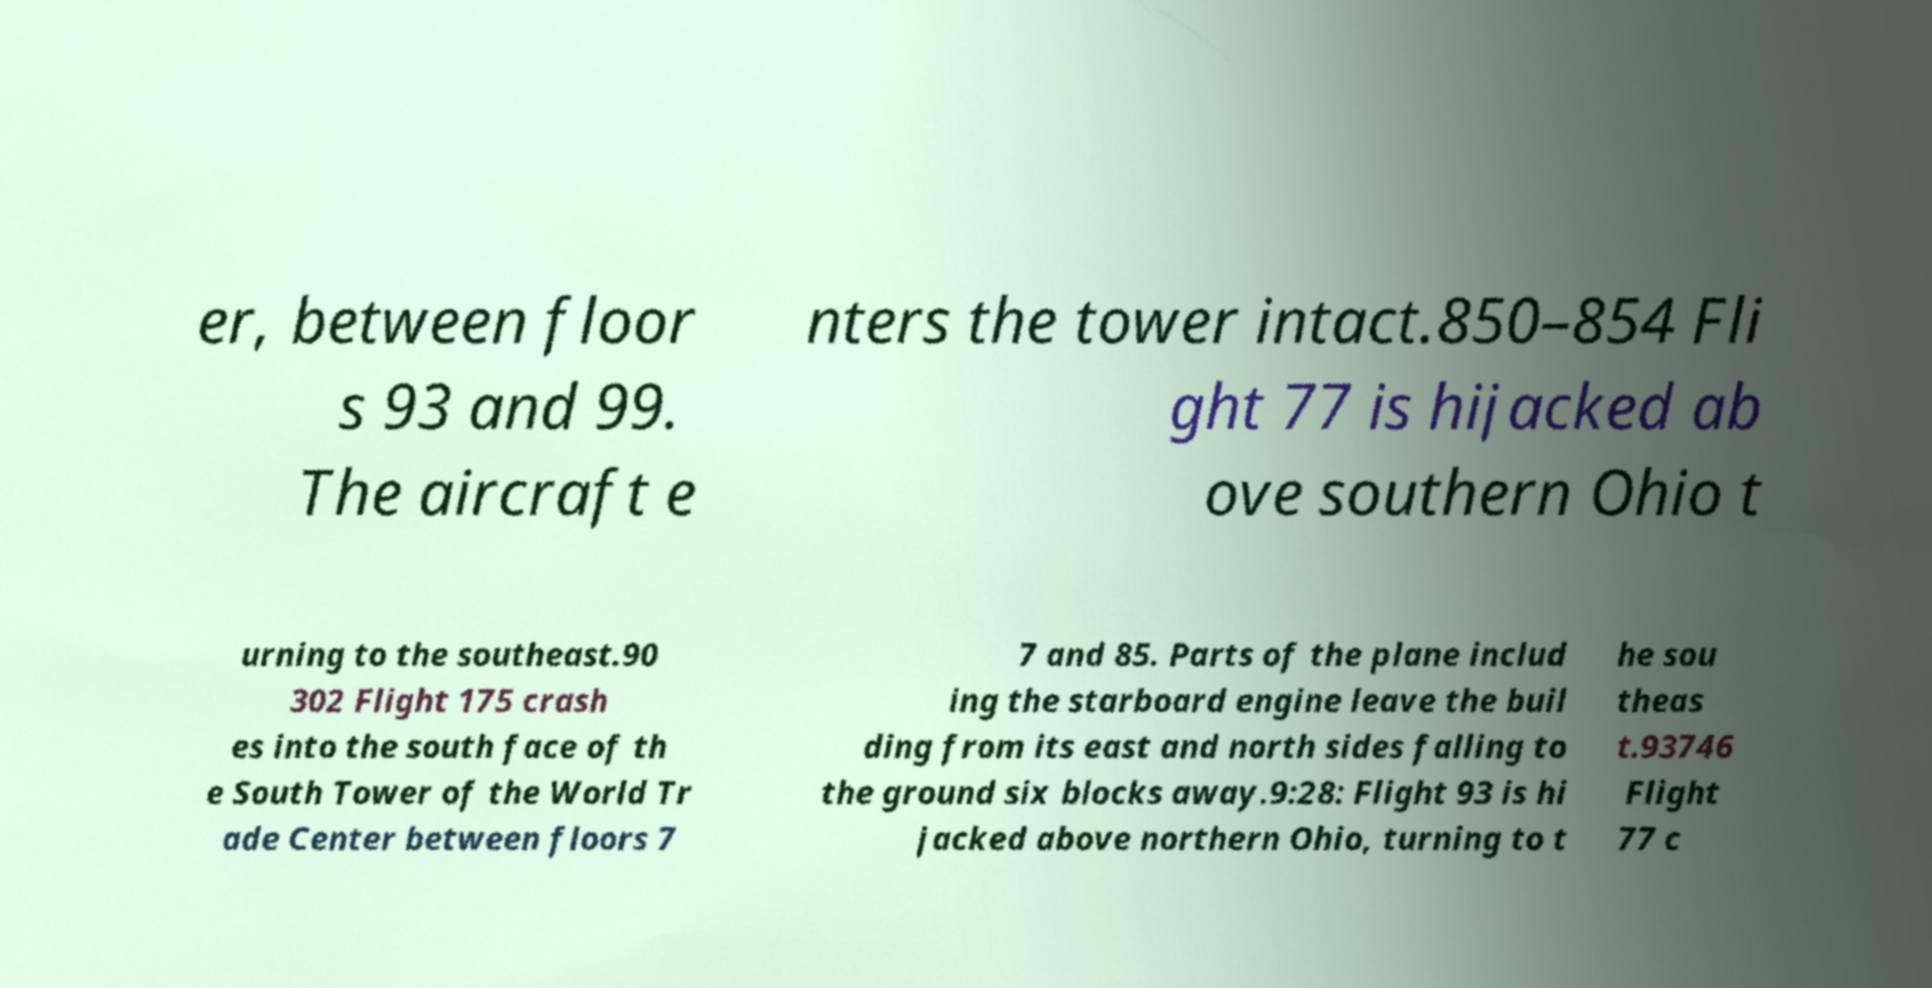Please identify and transcribe the text found in this image. er, between floor s 93 and 99. The aircraft e nters the tower intact.850–854 Fli ght 77 is hijacked ab ove southern Ohio t urning to the southeast.90 302 Flight 175 crash es into the south face of th e South Tower of the World Tr ade Center between floors 7 7 and 85. Parts of the plane includ ing the starboard engine leave the buil ding from its east and north sides falling to the ground six blocks away.9:28: Flight 93 is hi jacked above northern Ohio, turning to t he sou theas t.93746 Flight 77 c 